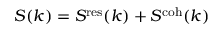Convert formula to latex. <formula><loc_0><loc_0><loc_500><loc_500>S ( k ) = S ^ { r e s } ( k ) + S ^ { c o h } ( k )</formula> 